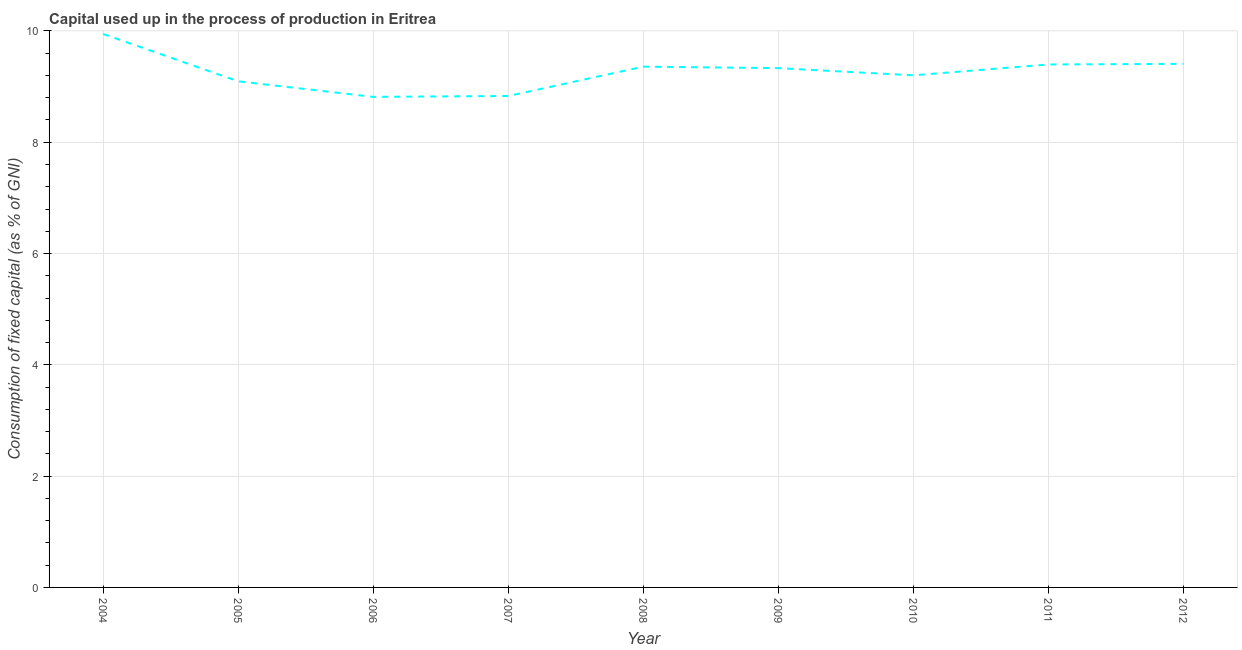What is the consumption of fixed capital in 2005?
Your answer should be compact. 9.09. Across all years, what is the maximum consumption of fixed capital?
Offer a very short reply. 9.95. Across all years, what is the minimum consumption of fixed capital?
Keep it short and to the point. 8.82. In which year was the consumption of fixed capital maximum?
Give a very brief answer. 2004. In which year was the consumption of fixed capital minimum?
Your answer should be compact. 2006. What is the sum of the consumption of fixed capital?
Make the answer very short. 83.38. What is the difference between the consumption of fixed capital in 2005 and 2010?
Make the answer very short. -0.11. What is the average consumption of fixed capital per year?
Your answer should be compact. 9.26. What is the median consumption of fixed capital?
Keep it short and to the point. 9.33. In how many years, is the consumption of fixed capital greater than 5.2 %?
Provide a short and direct response. 9. What is the ratio of the consumption of fixed capital in 2007 to that in 2010?
Your response must be concise. 0.96. What is the difference between the highest and the second highest consumption of fixed capital?
Ensure brevity in your answer.  0.54. Is the sum of the consumption of fixed capital in 2009 and 2010 greater than the maximum consumption of fixed capital across all years?
Your answer should be very brief. Yes. What is the difference between the highest and the lowest consumption of fixed capital?
Offer a terse response. 1.13. In how many years, is the consumption of fixed capital greater than the average consumption of fixed capital taken over all years?
Provide a succinct answer. 5. Does the consumption of fixed capital monotonically increase over the years?
Offer a terse response. No. How many lines are there?
Provide a short and direct response. 1. Are the values on the major ticks of Y-axis written in scientific E-notation?
Your answer should be very brief. No. Does the graph contain grids?
Give a very brief answer. Yes. What is the title of the graph?
Your response must be concise. Capital used up in the process of production in Eritrea. What is the label or title of the X-axis?
Your response must be concise. Year. What is the label or title of the Y-axis?
Keep it short and to the point. Consumption of fixed capital (as % of GNI). What is the Consumption of fixed capital (as % of GNI) in 2004?
Provide a succinct answer. 9.95. What is the Consumption of fixed capital (as % of GNI) in 2005?
Your response must be concise. 9.09. What is the Consumption of fixed capital (as % of GNI) in 2006?
Offer a terse response. 8.82. What is the Consumption of fixed capital (as % of GNI) in 2007?
Your answer should be compact. 8.83. What is the Consumption of fixed capital (as % of GNI) of 2008?
Your answer should be very brief. 9.36. What is the Consumption of fixed capital (as % of GNI) of 2009?
Make the answer very short. 9.33. What is the Consumption of fixed capital (as % of GNI) in 2010?
Give a very brief answer. 9.2. What is the Consumption of fixed capital (as % of GNI) in 2011?
Ensure brevity in your answer.  9.4. What is the Consumption of fixed capital (as % of GNI) in 2012?
Your answer should be very brief. 9.41. What is the difference between the Consumption of fixed capital (as % of GNI) in 2004 and 2005?
Your answer should be compact. 0.85. What is the difference between the Consumption of fixed capital (as % of GNI) in 2004 and 2006?
Your response must be concise. 1.13. What is the difference between the Consumption of fixed capital (as % of GNI) in 2004 and 2007?
Keep it short and to the point. 1.11. What is the difference between the Consumption of fixed capital (as % of GNI) in 2004 and 2008?
Your answer should be compact. 0.59. What is the difference between the Consumption of fixed capital (as % of GNI) in 2004 and 2009?
Ensure brevity in your answer.  0.61. What is the difference between the Consumption of fixed capital (as % of GNI) in 2004 and 2010?
Provide a short and direct response. 0.74. What is the difference between the Consumption of fixed capital (as % of GNI) in 2004 and 2011?
Offer a very short reply. 0.55. What is the difference between the Consumption of fixed capital (as % of GNI) in 2004 and 2012?
Offer a terse response. 0.54. What is the difference between the Consumption of fixed capital (as % of GNI) in 2005 and 2006?
Your answer should be compact. 0.28. What is the difference between the Consumption of fixed capital (as % of GNI) in 2005 and 2007?
Offer a terse response. 0.26. What is the difference between the Consumption of fixed capital (as % of GNI) in 2005 and 2008?
Ensure brevity in your answer.  -0.26. What is the difference between the Consumption of fixed capital (as % of GNI) in 2005 and 2009?
Your response must be concise. -0.24. What is the difference between the Consumption of fixed capital (as % of GNI) in 2005 and 2010?
Provide a short and direct response. -0.11. What is the difference between the Consumption of fixed capital (as % of GNI) in 2005 and 2011?
Your answer should be very brief. -0.3. What is the difference between the Consumption of fixed capital (as % of GNI) in 2005 and 2012?
Ensure brevity in your answer.  -0.31. What is the difference between the Consumption of fixed capital (as % of GNI) in 2006 and 2007?
Offer a very short reply. -0.02. What is the difference between the Consumption of fixed capital (as % of GNI) in 2006 and 2008?
Your response must be concise. -0.54. What is the difference between the Consumption of fixed capital (as % of GNI) in 2006 and 2009?
Keep it short and to the point. -0.52. What is the difference between the Consumption of fixed capital (as % of GNI) in 2006 and 2010?
Offer a terse response. -0.39. What is the difference between the Consumption of fixed capital (as % of GNI) in 2006 and 2011?
Keep it short and to the point. -0.58. What is the difference between the Consumption of fixed capital (as % of GNI) in 2006 and 2012?
Your answer should be very brief. -0.59. What is the difference between the Consumption of fixed capital (as % of GNI) in 2007 and 2008?
Provide a succinct answer. -0.53. What is the difference between the Consumption of fixed capital (as % of GNI) in 2007 and 2009?
Your response must be concise. -0.5. What is the difference between the Consumption of fixed capital (as % of GNI) in 2007 and 2010?
Give a very brief answer. -0.37. What is the difference between the Consumption of fixed capital (as % of GNI) in 2007 and 2011?
Provide a short and direct response. -0.57. What is the difference between the Consumption of fixed capital (as % of GNI) in 2007 and 2012?
Ensure brevity in your answer.  -0.58. What is the difference between the Consumption of fixed capital (as % of GNI) in 2008 and 2009?
Offer a very short reply. 0.03. What is the difference between the Consumption of fixed capital (as % of GNI) in 2008 and 2010?
Offer a very short reply. 0.16. What is the difference between the Consumption of fixed capital (as % of GNI) in 2008 and 2011?
Give a very brief answer. -0.04. What is the difference between the Consumption of fixed capital (as % of GNI) in 2008 and 2012?
Offer a terse response. -0.05. What is the difference between the Consumption of fixed capital (as % of GNI) in 2009 and 2010?
Ensure brevity in your answer.  0.13. What is the difference between the Consumption of fixed capital (as % of GNI) in 2009 and 2011?
Provide a succinct answer. -0.07. What is the difference between the Consumption of fixed capital (as % of GNI) in 2009 and 2012?
Offer a terse response. -0.08. What is the difference between the Consumption of fixed capital (as % of GNI) in 2010 and 2011?
Provide a succinct answer. -0.19. What is the difference between the Consumption of fixed capital (as % of GNI) in 2010 and 2012?
Your answer should be very brief. -0.21. What is the difference between the Consumption of fixed capital (as % of GNI) in 2011 and 2012?
Keep it short and to the point. -0.01. What is the ratio of the Consumption of fixed capital (as % of GNI) in 2004 to that in 2005?
Offer a terse response. 1.09. What is the ratio of the Consumption of fixed capital (as % of GNI) in 2004 to that in 2006?
Provide a succinct answer. 1.13. What is the ratio of the Consumption of fixed capital (as % of GNI) in 2004 to that in 2007?
Your answer should be very brief. 1.13. What is the ratio of the Consumption of fixed capital (as % of GNI) in 2004 to that in 2008?
Ensure brevity in your answer.  1.06. What is the ratio of the Consumption of fixed capital (as % of GNI) in 2004 to that in 2009?
Provide a short and direct response. 1.07. What is the ratio of the Consumption of fixed capital (as % of GNI) in 2004 to that in 2010?
Provide a succinct answer. 1.08. What is the ratio of the Consumption of fixed capital (as % of GNI) in 2004 to that in 2011?
Your answer should be compact. 1.06. What is the ratio of the Consumption of fixed capital (as % of GNI) in 2004 to that in 2012?
Make the answer very short. 1.06. What is the ratio of the Consumption of fixed capital (as % of GNI) in 2005 to that in 2006?
Make the answer very short. 1.03. What is the ratio of the Consumption of fixed capital (as % of GNI) in 2005 to that in 2009?
Your response must be concise. 0.97. What is the ratio of the Consumption of fixed capital (as % of GNI) in 2005 to that in 2011?
Make the answer very short. 0.97. What is the ratio of the Consumption of fixed capital (as % of GNI) in 2006 to that in 2008?
Ensure brevity in your answer.  0.94. What is the ratio of the Consumption of fixed capital (as % of GNI) in 2006 to that in 2009?
Ensure brevity in your answer.  0.94. What is the ratio of the Consumption of fixed capital (as % of GNI) in 2006 to that in 2010?
Keep it short and to the point. 0.96. What is the ratio of the Consumption of fixed capital (as % of GNI) in 2006 to that in 2011?
Your answer should be very brief. 0.94. What is the ratio of the Consumption of fixed capital (as % of GNI) in 2006 to that in 2012?
Offer a terse response. 0.94. What is the ratio of the Consumption of fixed capital (as % of GNI) in 2007 to that in 2008?
Make the answer very short. 0.94. What is the ratio of the Consumption of fixed capital (as % of GNI) in 2007 to that in 2009?
Ensure brevity in your answer.  0.95. What is the ratio of the Consumption of fixed capital (as % of GNI) in 2007 to that in 2010?
Offer a terse response. 0.96. What is the ratio of the Consumption of fixed capital (as % of GNI) in 2007 to that in 2011?
Your response must be concise. 0.94. What is the ratio of the Consumption of fixed capital (as % of GNI) in 2007 to that in 2012?
Your answer should be very brief. 0.94. What is the ratio of the Consumption of fixed capital (as % of GNI) in 2008 to that in 2010?
Your answer should be very brief. 1.02. What is the ratio of the Consumption of fixed capital (as % of GNI) in 2008 to that in 2011?
Your answer should be very brief. 1. What is the ratio of the Consumption of fixed capital (as % of GNI) in 2009 to that in 2011?
Your response must be concise. 0.99. What is the ratio of the Consumption of fixed capital (as % of GNI) in 2010 to that in 2011?
Make the answer very short. 0.98. What is the ratio of the Consumption of fixed capital (as % of GNI) in 2010 to that in 2012?
Make the answer very short. 0.98. 